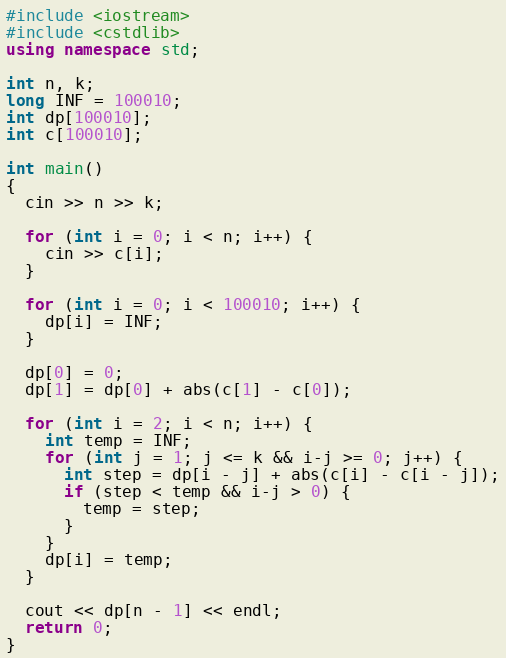<code> <loc_0><loc_0><loc_500><loc_500><_C++_>#include <iostream>
#include <cstdlib>
using namespace std;

int n, k;
long INF = 100010;
int dp[100010];
int c[100010];

int main()
{
  cin >> n >> k;

  for (int i = 0; i < n; i++) {
    cin >> c[i];
  }

  for (int i = 0; i < 100010; i++) {
    dp[i] = INF;
  }

  dp[0] = 0;
  dp[1] = dp[0] + abs(c[1] - c[0]);
  
  for (int i = 2; i < n; i++) {
    int temp = INF;
    for (int j = 1; j <= k && i-j >= 0; j++) {
      int step = dp[i - j] + abs(c[i] - c[i - j]);
      if (step < temp && i-j > 0) {
        temp = step;
      }
    }
    dp[i] = temp;
  }

  cout << dp[n - 1] << endl;
  return 0;
}</code> 